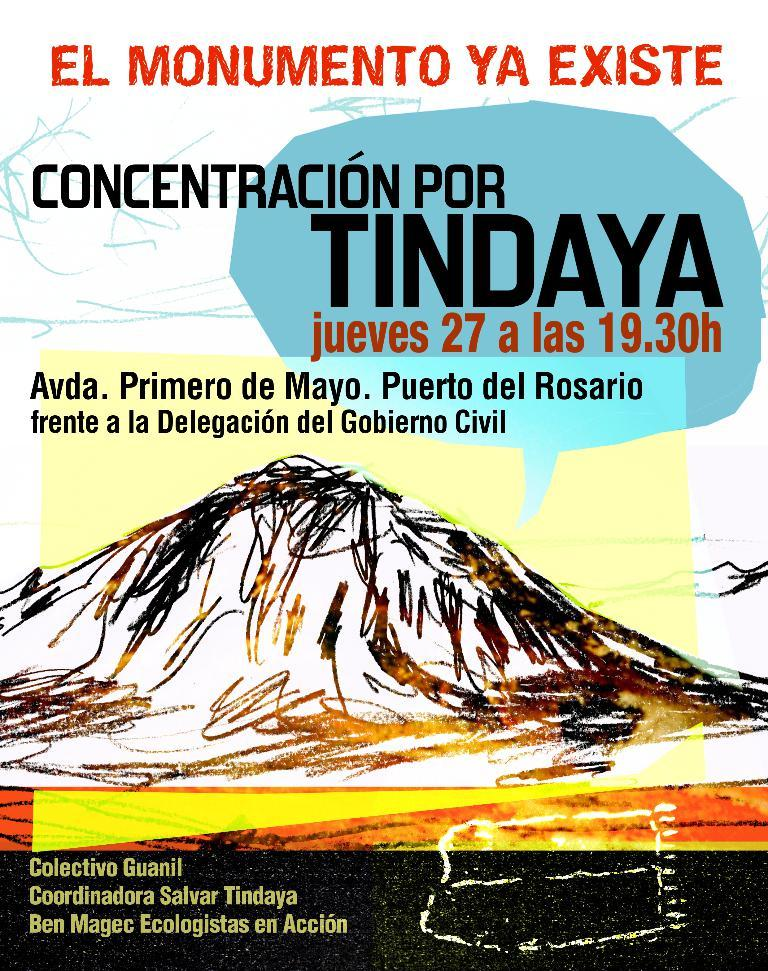What can be seen in the image related to a visual display? There is a poster in the image. What is featured on the poster? There is writing on the poster. Reasoning: Let's think step by step by step in order to produce the conversation. We start by identifying the main subject in the image, which is the poster. Then, we expand the conversation to include the specific details about the poster, such as the presence of writing on it. Each question is designed to elicit a specific detail about the image that is known from the provided facts. Absurd Question/Answer: Can you tell me how many quarters are shown on the map in the image? There is no map or quarters present in the image; it only features a poster with writing on it. Is there a beggar visible in the image? There is no beggar present in the image; it only features a poster with writing on it. 